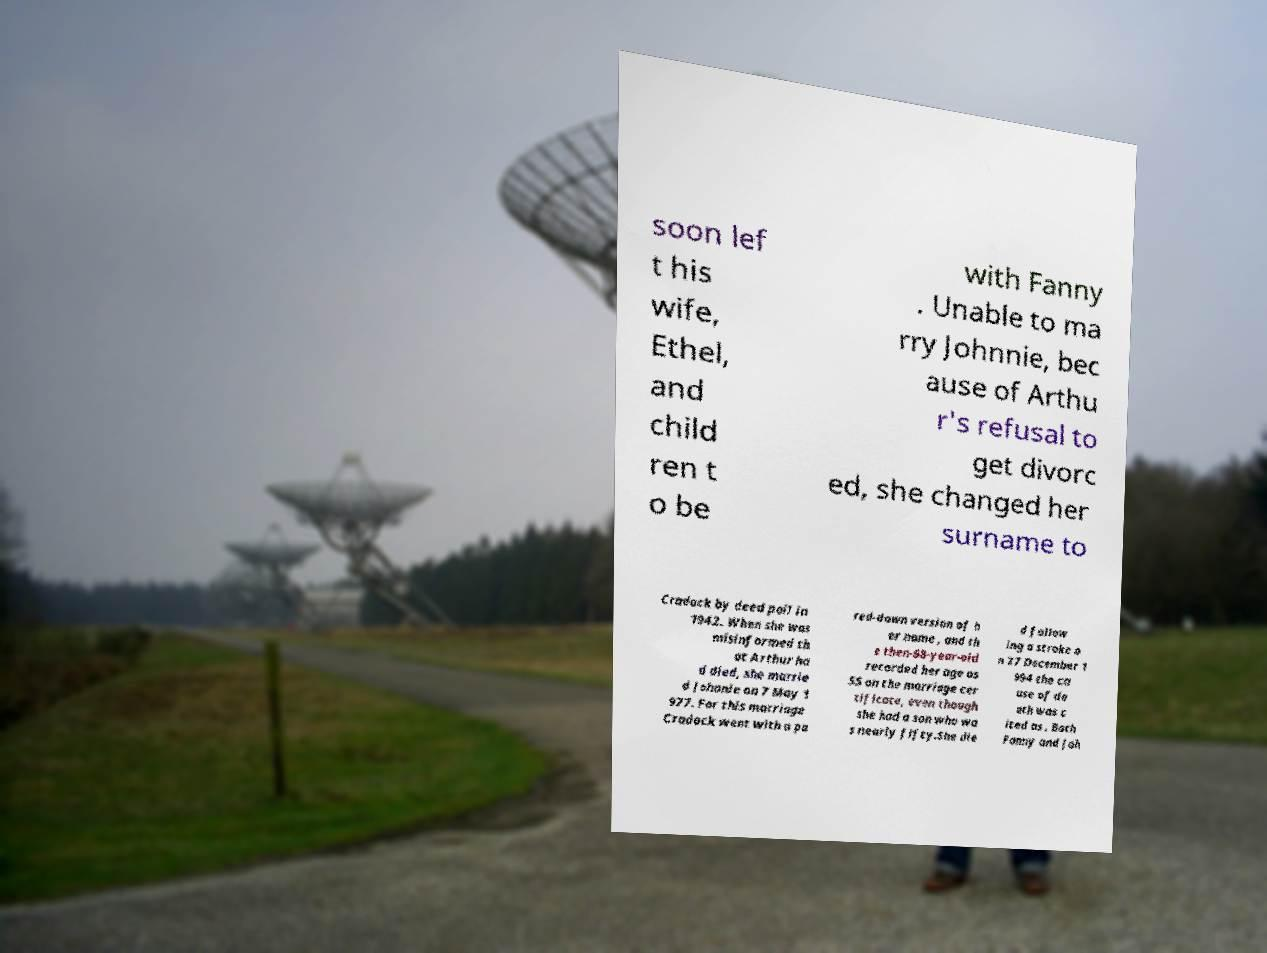Could you assist in decoding the text presented in this image and type it out clearly? soon lef t his wife, Ethel, and child ren t o be with Fanny . Unable to ma rry Johnnie, bec ause of Arthu r's refusal to get divorc ed, she changed her surname to Cradock by deed poll in 1942. When she was misinformed th at Arthur ha d died, she marrie d Johnnie on 7 May 1 977. For this marriage Cradock went with a pa red-down version of h er name , and th e then-68-year-old recorded her age as 55 on the marriage cer tificate, even though she had a son who wa s nearly fifty.She die d follow ing a stroke o n 27 December 1 994 the ca use of de ath was c ited as . Both Fanny and Joh 